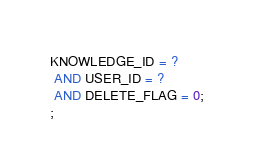<code> <loc_0><loc_0><loc_500><loc_500><_SQL_>KNOWLEDGE_ID = ?
 AND USER_ID = ?
 AND DELETE_FLAG = 0;
;
</code> 